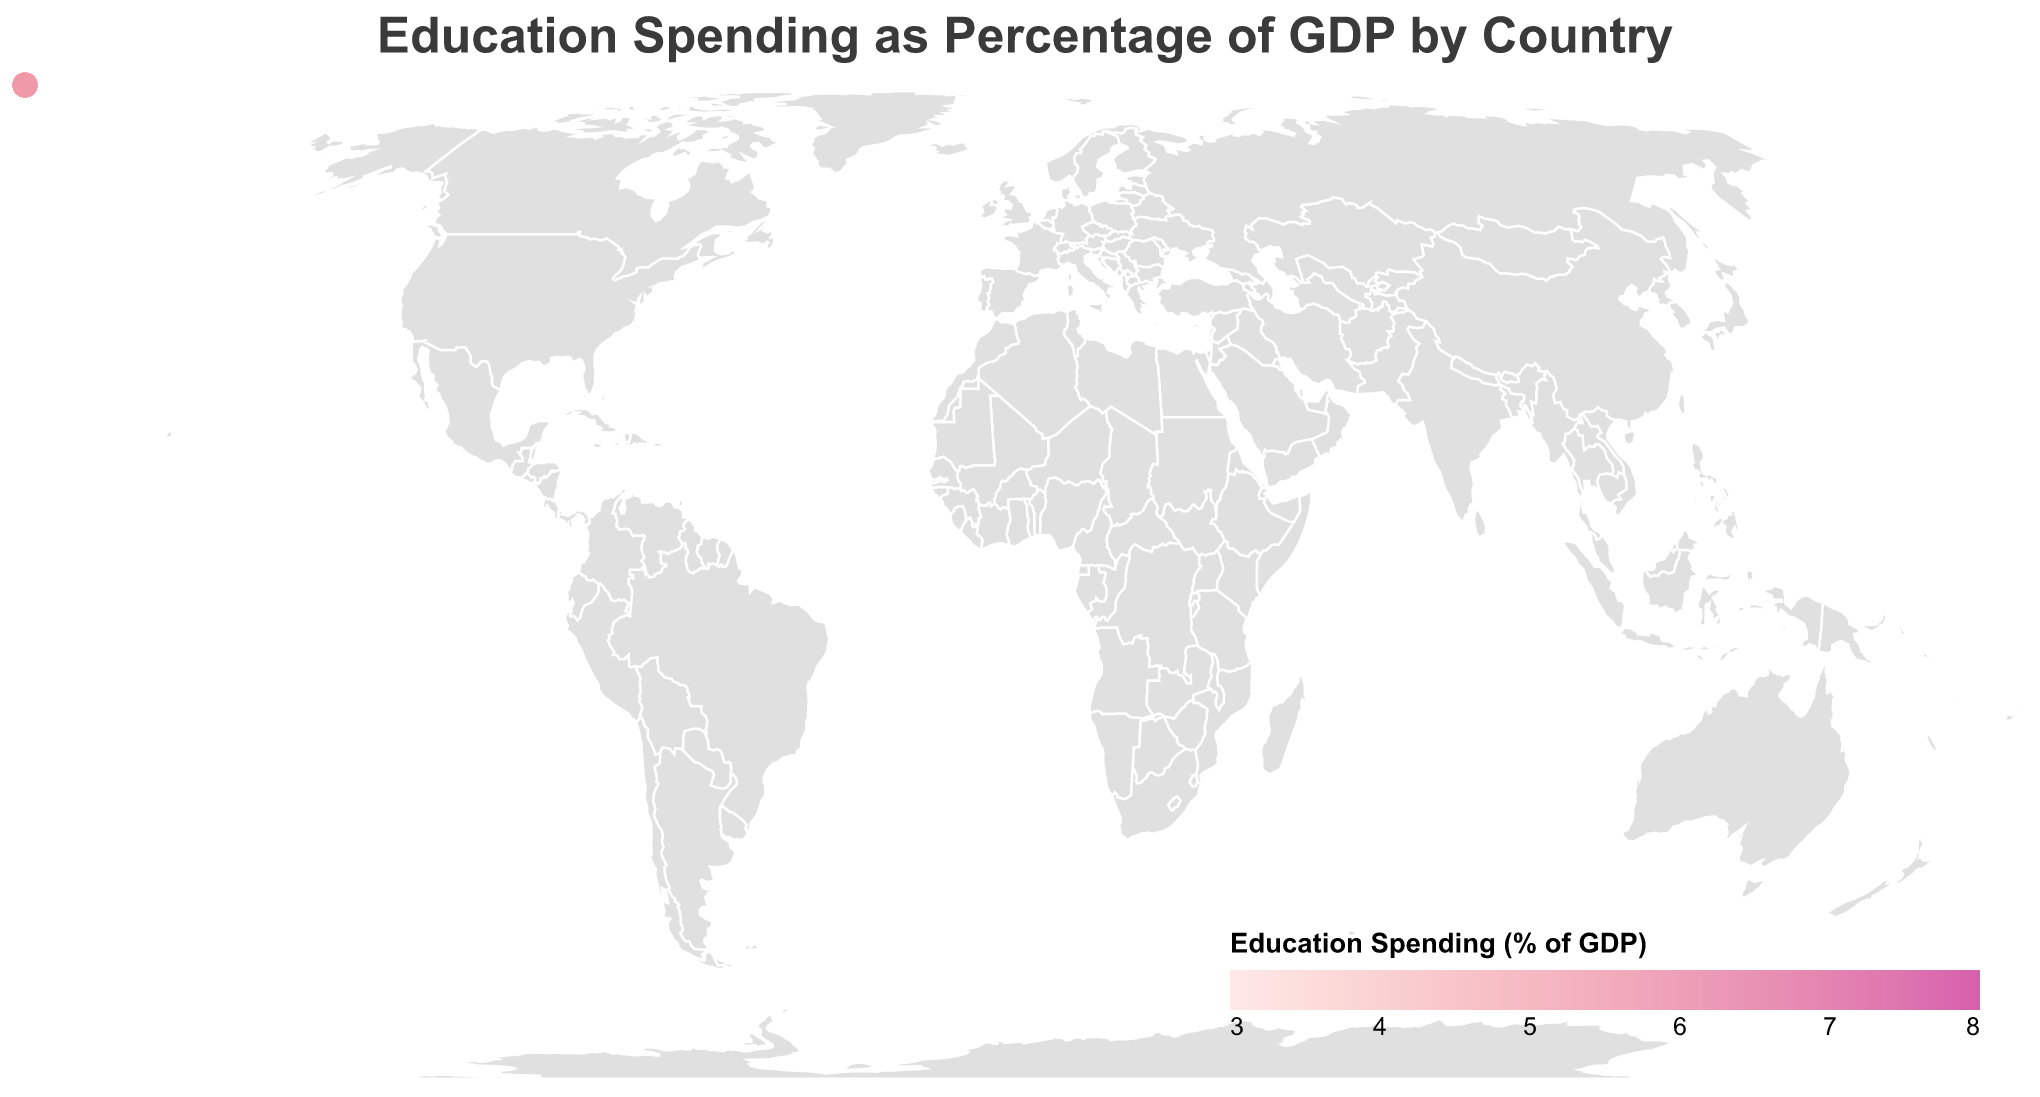What is the title of the figure? The title is usually displayed at the top of the figure. It helps give a brief overview of the subject matter being visualized. The title displayed in the figure is "Education Spending as Percentage of GDP by Country"
Answer: Education Spending as Percentage of GDP by Country Which country has the highest education spending as a percentage of GDP? This can be identified by the color gradient depicted in the figure. The countries with the darkest color have the highest spending. Norway, with a spending of 7.9%, has the highest education spending.
Answer: Norway Which countries have an education spending percentage of GDP between 7.5% and 7.9%? By examining the color shades and corresponding tooltip information, you can identify that Denmark (7.8%), Sweden (7.6%), and Iceland (7.5%) fall within this range.
Answer: Denmark, Sweden, Iceland What is the average education spending percentage of GDP for the Scandinavian countries listed in the data? Scandinavian countries in the list are Norway, Denmark, and Sweden. The average is calculated as follows: (7.9 + 7.8 + 7.6) / 3 = 7.7667.
Answer: 7.77 Which country spends less on education as a percentage of GDP compared to Germany? Germany spends 4.9% of its GDP on education. Countries spending less than this would have lighter colors in the shade. Japan (3.5%), Mexico (4.5%), India (3.8%), China (3.5%), Egypt (3.8%), Turkey (4.3%), Italy (4.1%), and Spain (4.2%) all spend less.
Answer: Japan, Mexico, India, China, Egypt, Turkey, Italy, Spain What is the difference in education spending percentage between the United States and South Africa? The United States allocates 5.0% while South Africa allocates 6.5% of their GDPs to education. The difference is calculated as 6.5 - 5.0 = 1.5.
Answer: 1.5 Which country has the lowest education spending as a percentage of GDP and what is its value? By identifying the lightest color shade and corresponding tooltip, Japan and China emerge as the countries with the lowest spending at 3.5%.
Answer: Japan, China Are there any countries within the dataset that have an equal education spending percentage of GDP? By cross-referencing the data, Japan and China both have an education spending of 3.5%, and Kenya and Canada both at 5.3%.
Answer: Japan and China; Kenya and Canada What is the range of education spending as a percentage of GDP among the countries in the figure? The range can be determined by subtracting the lowest value (3.5% for Japan and China) from the highest value (7.9% for Norway). So, 7.9 - 3.5 = 4.4.
Answer: 4.4 